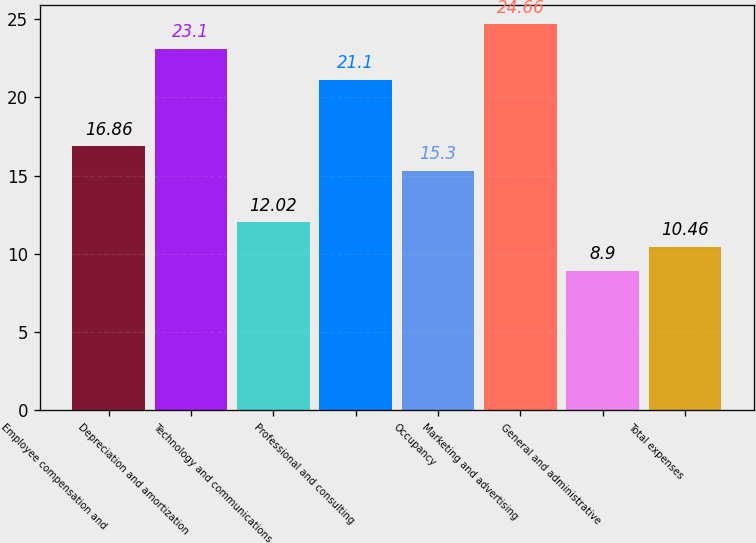Convert chart. <chart><loc_0><loc_0><loc_500><loc_500><bar_chart><fcel>Employee compensation and<fcel>Depreciation and amortization<fcel>Technology and communications<fcel>Professional and consulting<fcel>Occupancy<fcel>Marketing and advertising<fcel>General and administrative<fcel>Total expenses<nl><fcel>16.86<fcel>23.1<fcel>12.02<fcel>21.1<fcel>15.3<fcel>24.66<fcel>8.9<fcel>10.46<nl></chart> 